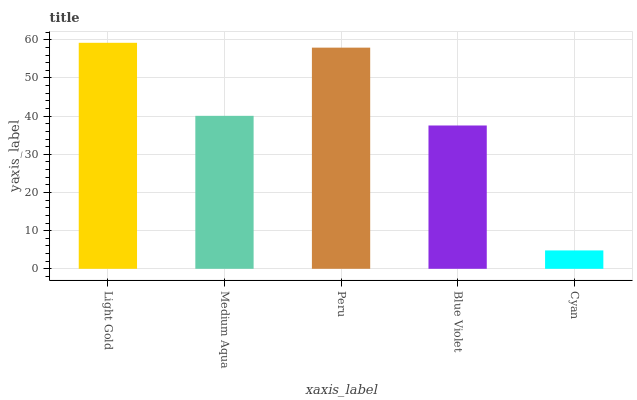Is Medium Aqua the minimum?
Answer yes or no. No. Is Medium Aqua the maximum?
Answer yes or no. No. Is Light Gold greater than Medium Aqua?
Answer yes or no. Yes. Is Medium Aqua less than Light Gold?
Answer yes or no. Yes. Is Medium Aqua greater than Light Gold?
Answer yes or no. No. Is Light Gold less than Medium Aqua?
Answer yes or no. No. Is Medium Aqua the high median?
Answer yes or no. Yes. Is Medium Aqua the low median?
Answer yes or no. Yes. Is Cyan the high median?
Answer yes or no. No. Is Cyan the low median?
Answer yes or no. No. 